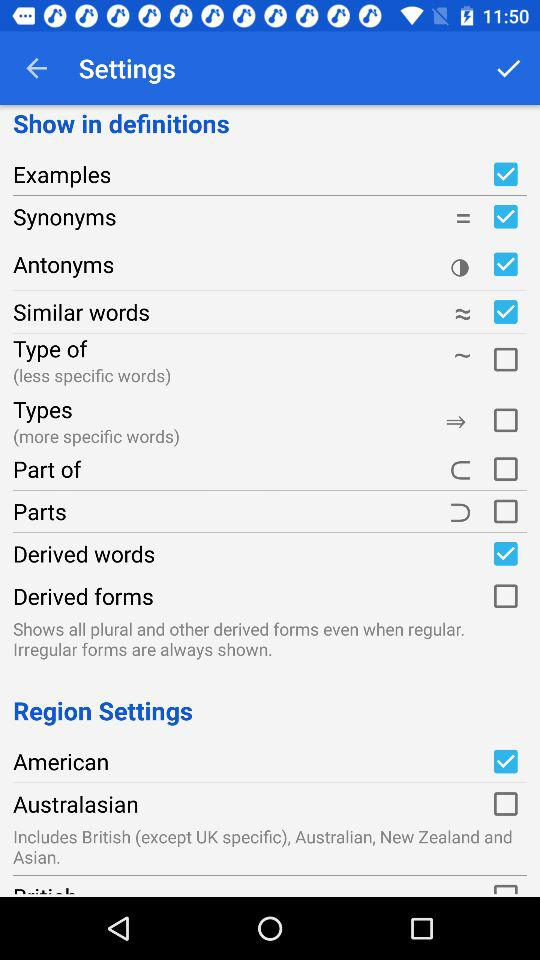What is the status of the "Type of"? The status is "off". 